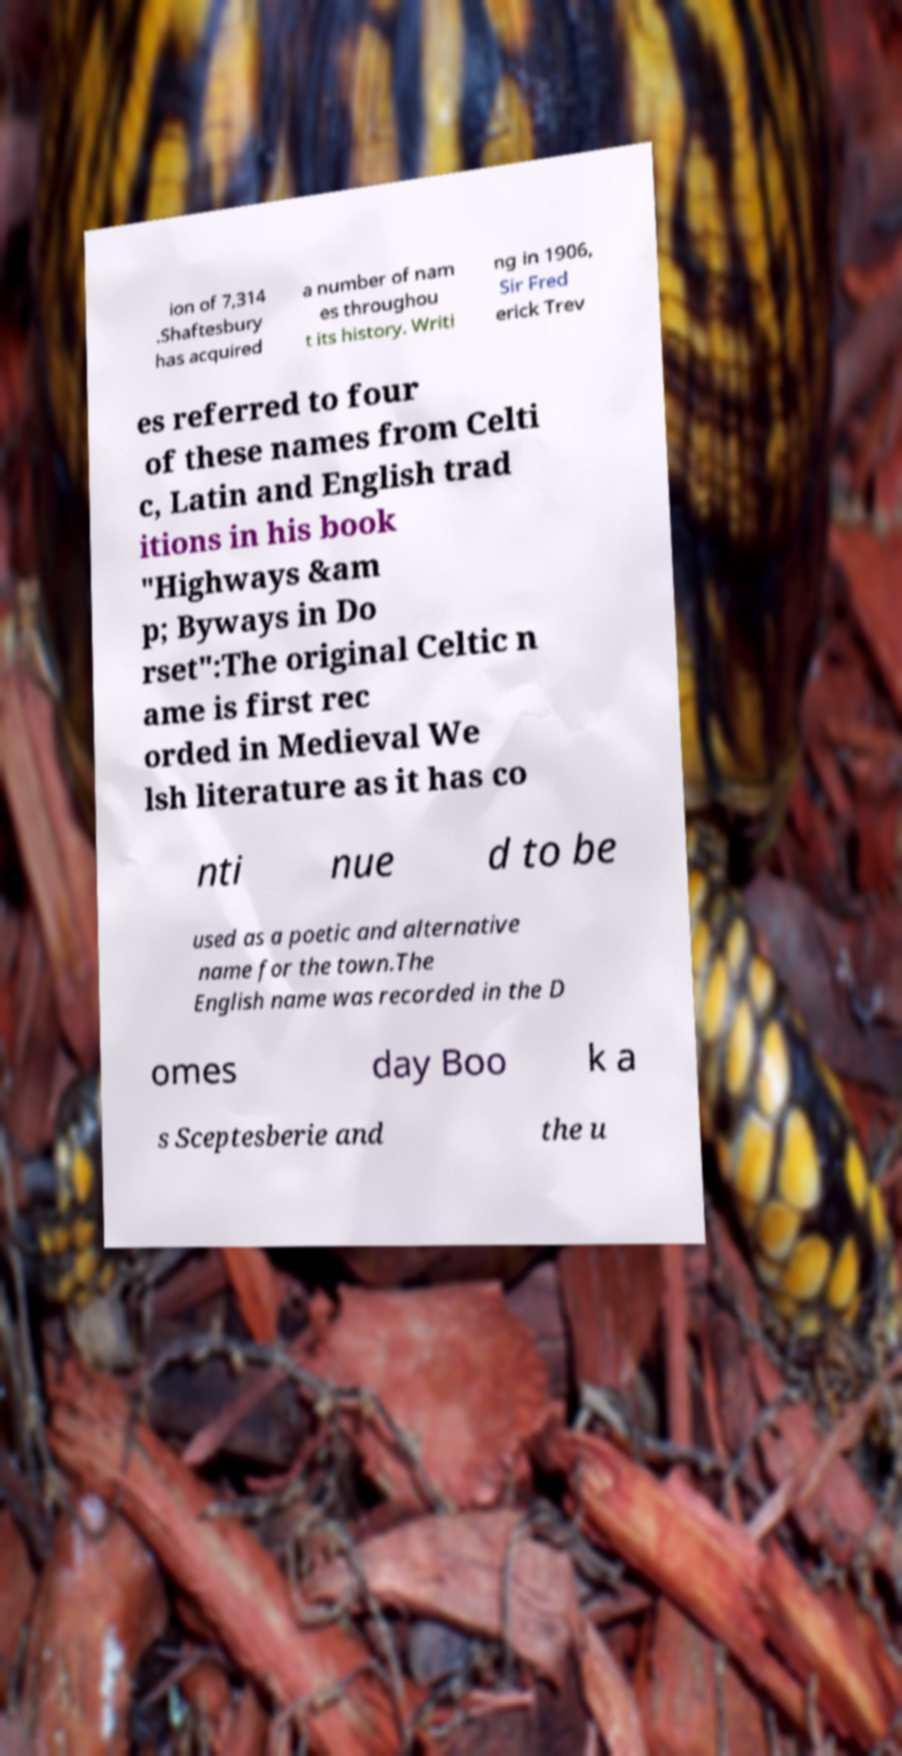I need the written content from this picture converted into text. Can you do that? ion of 7,314 .Shaftesbury has acquired a number of nam es throughou t its history. Writi ng in 1906, Sir Fred erick Trev es referred to four of these names from Celti c, Latin and English trad itions in his book "Highways &am p; Byways in Do rset":The original Celtic n ame is first rec orded in Medieval We lsh literature as it has co nti nue d to be used as a poetic and alternative name for the town.The English name was recorded in the D omes day Boo k a s Sceptesberie and the u 